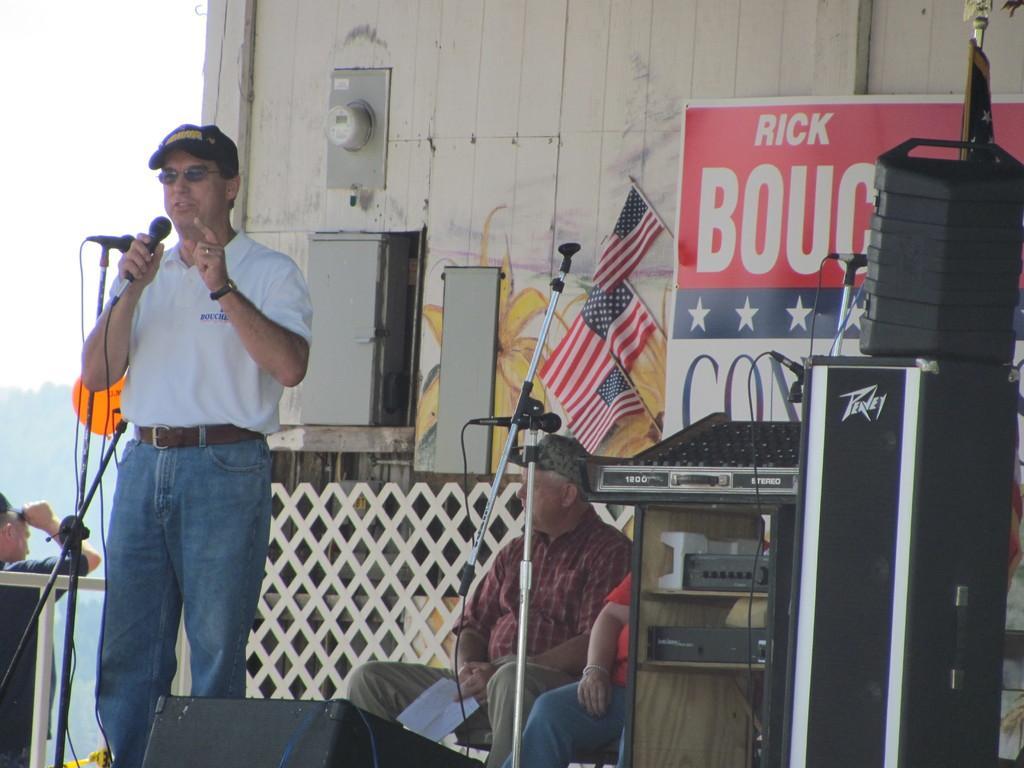Could you give a brief overview of what you see in this image? In the center of the image we can see two persons are sitting and one person is standing. Among them, we can see two persons are wearing caps, two persons are holding some objects and one person is wearing glasses. And we can see the wooden wall, speakers, shelves, tables, electronic objects, stands, microphones, one banner, flags and a few other objects. On the banner, we can see some text. In the background we can see the sky, clouds, trees, one person standing and a few other objects. 